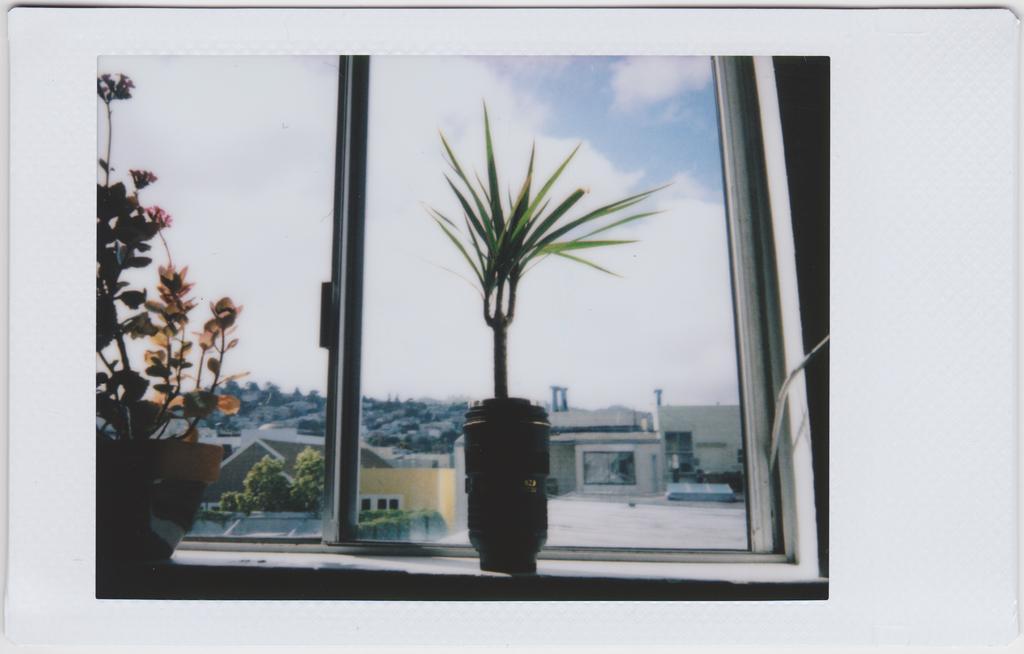Please provide a concise description of this image. In this image, we can see photograph on the white card. In this photograph, we can see house plants and glass window. Through the glass window, we can see the outside view. We can see trees, houses and the sky. 